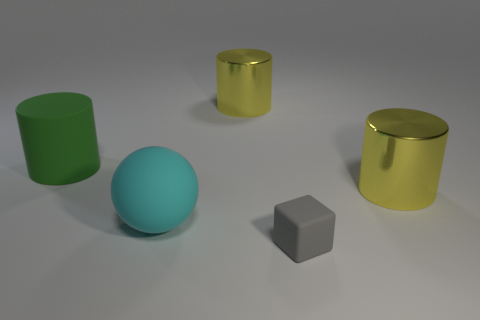Are there any other things that are the same size as the matte cube?
Your answer should be compact. No. Is there anything else that is the same shape as the gray rubber object?
Your answer should be very brief. No. What color is the matte object that is behind the yellow thing in front of the big yellow cylinder left of the tiny gray block?
Make the answer very short. Green. Are there any yellow objects that have the same shape as the green object?
Ensure brevity in your answer.  Yes. Is the number of big objects on the right side of the green rubber cylinder the same as the number of big yellow metal things to the left of the gray thing?
Provide a short and direct response. No. Is the shape of the big metallic object that is on the left side of the small gray matte block the same as  the big green matte object?
Provide a short and direct response. Yes. How many metallic things are either blocks or big objects?
Your answer should be compact. 2. Do the sphere and the matte block have the same size?
Your response must be concise. No. What number of things are either tiny cyan cylinders or yellow metal cylinders that are behind the green cylinder?
Give a very brief answer. 1. There is a cyan sphere that is the same size as the matte cylinder; what is its material?
Your answer should be compact. Rubber. 